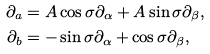<formula> <loc_0><loc_0><loc_500><loc_500>\partial _ { a } & = A \cos \sigma \partial _ { \alpha } + A \sin \sigma \partial _ { \beta } , \\ \partial _ { b } & = - \sin \sigma \partial _ { \alpha } + \cos \sigma \partial _ { \beta } ,</formula> 